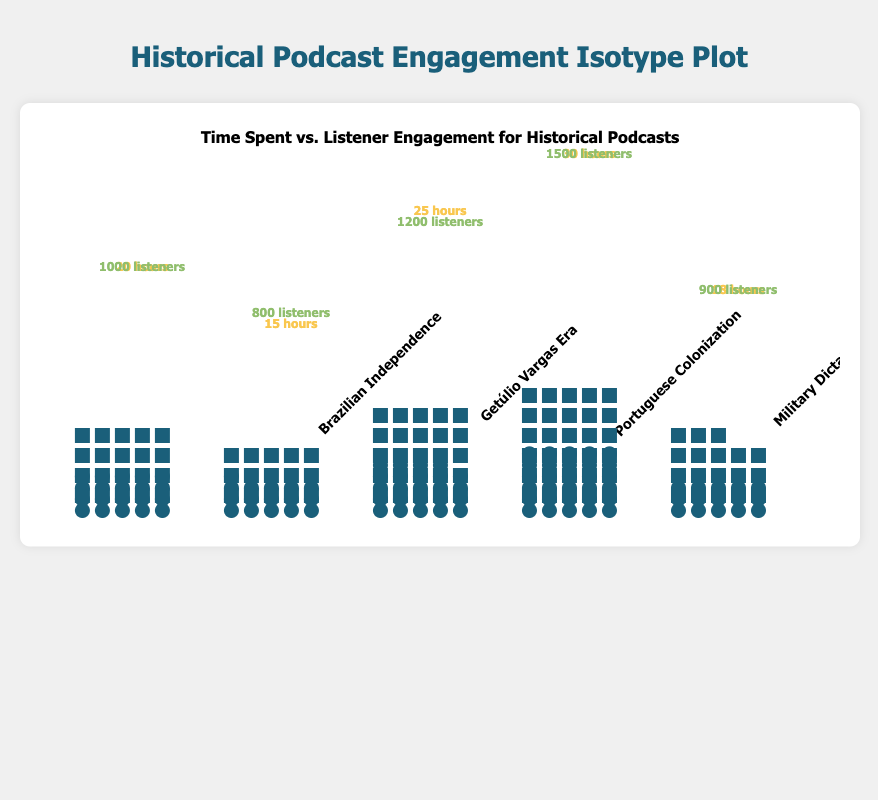Which topic had the highest number of listener engagements? The tallest bar of green circles in the chart represents "Military Dictatorship," indicating it had the highest number of listener engagements.
Answer: Military Dictatorship What is the total hours spent on "Brazilian Independence" and "Portuguese Colonization"? Add the hours spent on "Brazilian Independence" and "Portuguese Colonization": 20 + 25.
Answer: 45 Which topic had the lowest hours spent on podcast creation? The lowest stack of yellow rectangles represents "Getúlio Vargas Era," indicating it had the fewest hours spent on creation.
Answer: Getúlio Vargas Era How much higher is the listener engagement for "Military Dictatorship" compared to "Getúlio Vargas Era"? Subtract the listener engagement of "Getúlio Vargas Era" from "Military Dictatorship": 1500 - 800.
Answer: 700 Which topics required more than 20 hours of creation? Identify bars with more than 20 yellow rectangles: "Portuguese Colonization" and "Military Dictatorship."
Answer: Portuguese Colonization, Military Dictatorship What is the average listener engagement across all topics? Sum all listener engagements: 1000 + 800 + 1200 + 1500 + 900; then divide by 5. (5400 / 5)
Answer: 1080 Which topic had a higher engagement, "Portuguese Colonization" or "Brazilian Independence"? Compare the heights of green circles for both topics. "Portuguese Colonization" had 1200 engagements, while "Brazilian Independence" had 1000.
Answer: Portuguese Colonization What ratio of listener engagement to hours spent does "Abolition of Slavery" have? Divide the listener engagement by hours spent for "Abolition of Slavery": 900 / 18.
Answer: 50 listeners per hour How does the engagement trend relate to the hours spent on podcast creation? Observe the general pattern in the chart: Higher hours spent on creation (like "Military Dictatorship") tend to show higher listener engagement.
Answer: Higher hours spent generally correlate with higher engagement 